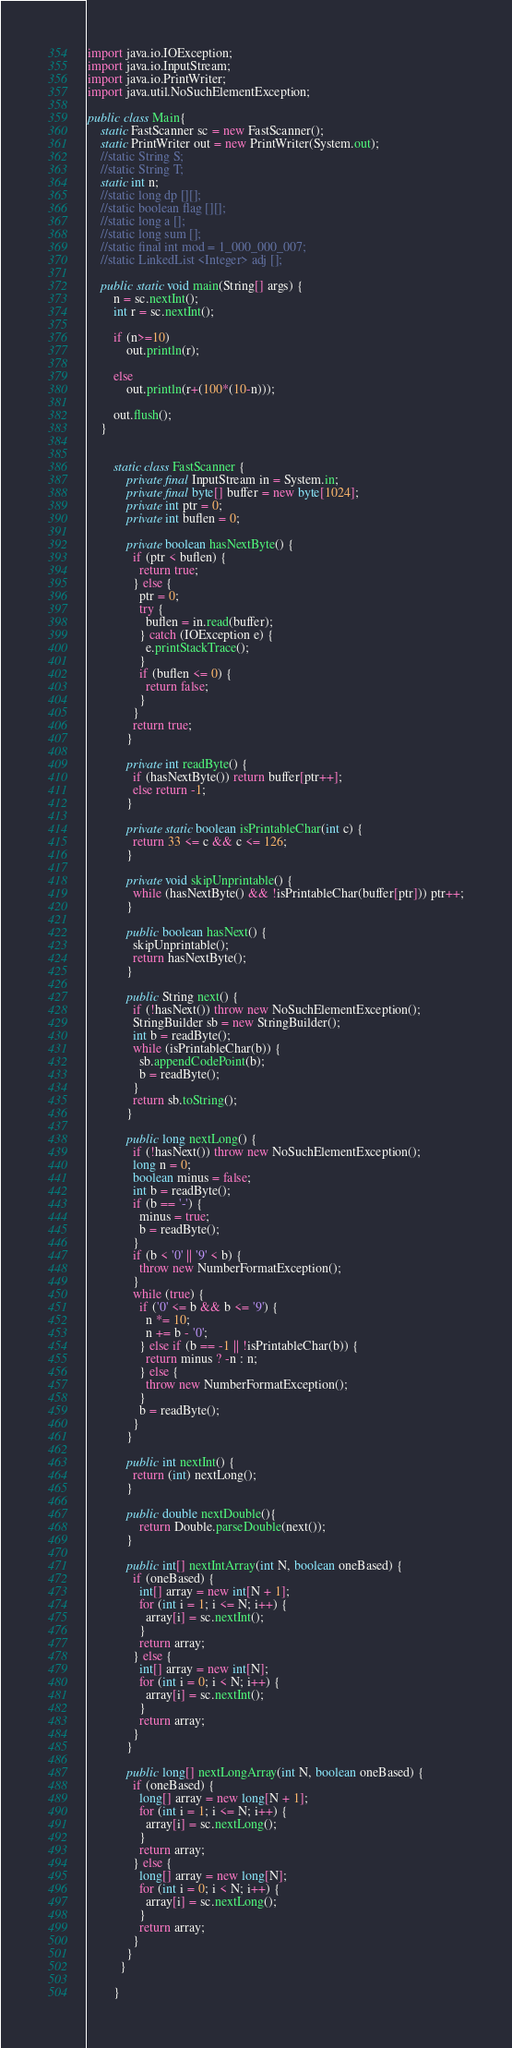Convert code to text. <code><loc_0><loc_0><loc_500><loc_500><_Java_>import java.io.IOException;
import java.io.InputStream;
import java.io.PrintWriter;
import java.util.NoSuchElementException;

public class Main{
	static FastScanner sc = new FastScanner();
	static PrintWriter out = new PrintWriter(System.out);
	//static String S;
	//static String T;
	static int n;
	//static long dp [][];
	//static boolean flag [][];
	//static long a [];
	//static long sum [];
	//static final int mod = 1_000_000_007;
	//static LinkedList <Integer> adj []; 
	
	public static void main(String[] args) {
		n = sc.nextInt();
		int r = sc.nextInt();
		
		if (n>=10)
			out.println(r);
		
		else 
			out.println(r+(100*(10-n)));
		
		out.flush();
	}
	
	
		static class FastScanner {
		    private final InputStream in = System.in;
		    private final byte[] buffer = new byte[1024];
		    private int ptr = 0;
		    private int buflen = 0;

		    private boolean hasNextByte() {
		      if (ptr < buflen) {
		        return true;
		      } else {
		        ptr = 0;
		        try {
		          buflen = in.read(buffer);
		        } catch (IOException e) {
		          e.printStackTrace();
		        }
		        if (buflen <= 0) {
		          return false;
		        }
		      }
		      return true;
		    }

		    private int readByte() {
		      if (hasNextByte()) return buffer[ptr++];
		      else return -1;
		    }

		    private static boolean isPrintableChar(int c) {
		      return 33 <= c && c <= 126;
		    }

		    private void skipUnprintable() {
		      while (hasNextByte() && !isPrintableChar(buffer[ptr])) ptr++;
		    }

		    public boolean hasNext() {
		      skipUnprintable();
		      return hasNextByte();
		    }

		    public String next() {
		      if (!hasNext()) throw new NoSuchElementException();
		      StringBuilder sb = new StringBuilder();
		      int b = readByte();
		      while (isPrintableChar(b)) {
		        sb.appendCodePoint(b);
		        b = readByte();
		      }
		      return sb.toString();
		    }

		    public long nextLong() {
		      if (!hasNext()) throw new NoSuchElementException();
		      long n = 0;
		      boolean minus = false;
		      int b = readByte();
		      if (b == '-') {
		        minus = true;
		        b = readByte();
		      }
		      if (b < '0' || '9' < b) {
		        throw new NumberFormatException();
		      }
		      while (true) {
		        if ('0' <= b && b <= '9') {
		          n *= 10;
		          n += b - '0';
		        } else if (b == -1 || !isPrintableChar(b)) {
		          return minus ? -n : n;
		        } else {
		          throw new NumberFormatException();
		        }
		        b = readByte();
		      }
		    }

		    public int nextInt() {
		      return (int) nextLong();
		    }
		    
		    public double nextDouble(){
		    	return Double.parseDouble(next());
		    }

		    public int[] nextIntArray(int N, boolean oneBased) {
		      if (oneBased) {
		        int[] array = new int[N + 1];
		        for (int i = 1; i <= N; i++) {
		          array[i] = sc.nextInt();
		        }
		        return array;
		      } else {
		        int[] array = new int[N];
		        for (int i = 0; i < N; i++) {
		          array[i] = sc.nextInt();
		        }
		        return array;
		      }
		    }

		    public long[] nextLongArray(int N, boolean oneBased) {
		      if (oneBased) {
		        long[] array = new long[N + 1];
		        for (int i = 1; i <= N; i++) {
		          array[i] = sc.nextLong();
		        }
		        return array;
		      } else {
		        long[] array = new long[N];
		        for (int i = 0; i < N; i++) {
		          array[i] = sc.nextLong();
		        }
		        return array;
		      }
		    }
		  }

		}	 



</code> 